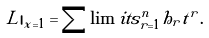Convert formula to latex. <formula><loc_0><loc_0><loc_500><loc_500>L | _ { x = 1 } = \sum \lim i t s _ { r = 1 } ^ { n } h _ { r } t ^ { r } .</formula> 